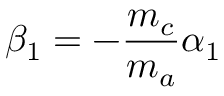<formula> <loc_0><loc_0><loc_500><loc_500>\beta _ { 1 } = - \frac { m _ { c } } { m _ { a } } \alpha _ { 1 }</formula> 